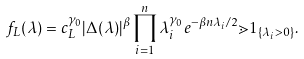Convert formula to latex. <formula><loc_0><loc_0><loc_500><loc_500>f _ { L } ( \lambda ) = c _ { L } ^ { \gamma _ { 0 } } | \Delta ( \lambda ) | ^ { \beta } \prod _ { i = 1 } ^ { n } \lambda _ { i } ^ { \gamma _ { 0 } } e ^ { - \beta n \lambda _ { i } / 2 } \mathbb { m } { 1 } _ { \{ \lambda _ { i } > 0 \} } .</formula> 